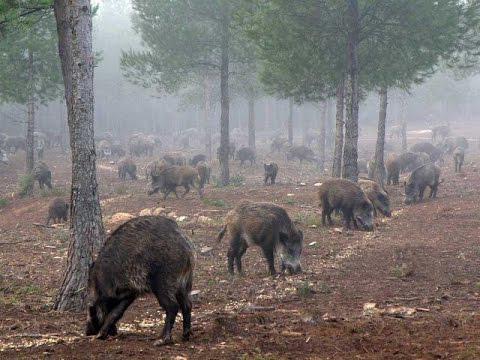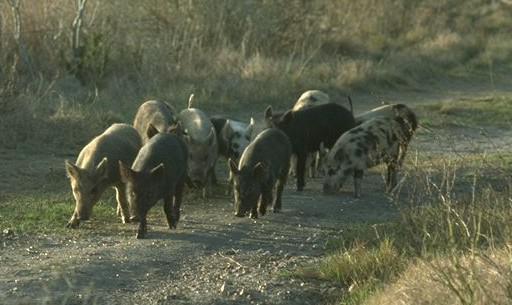The first image is the image on the left, the second image is the image on the right. Assess this claim about the two images: "There is a man made object in a field in one of the images.". Correct or not? Answer yes or no. No. The first image is the image on the left, the second image is the image on the right. Analyze the images presented: Is the assertion "A group of hogs is garthered near a barrel-shaped feeder on a tripod." valid? Answer yes or no. No. 